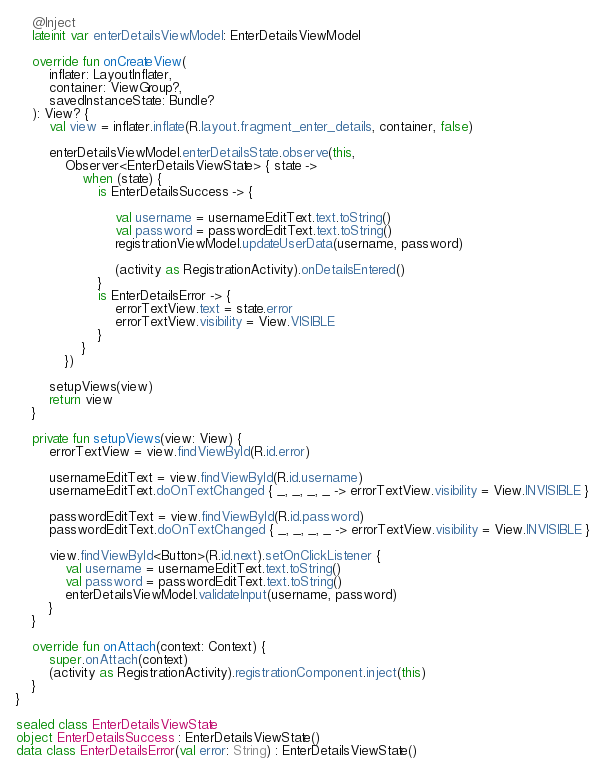<code> <loc_0><loc_0><loc_500><loc_500><_Kotlin_>    @Inject
    lateinit var enterDetailsViewModel: EnterDetailsViewModel

    override fun onCreateView(
        inflater: LayoutInflater,
        container: ViewGroup?,
        savedInstanceState: Bundle?
    ): View? {
        val view = inflater.inflate(R.layout.fragment_enter_details, container, false)

        enterDetailsViewModel.enterDetailsState.observe(this,
            Observer<EnterDetailsViewState> { state ->
                when (state) {
                    is EnterDetailsSuccess -> {

                        val username = usernameEditText.text.toString()
                        val password = passwordEditText.text.toString()
                        registrationViewModel.updateUserData(username, password)

                        (activity as RegistrationActivity).onDetailsEntered()
                    }
                    is EnterDetailsError -> {
                        errorTextView.text = state.error
                        errorTextView.visibility = View.VISIBLE
                    }
                }
            })

        setupViews(view)
        return view
    }

    private fun setupViews(view: View) {
        errorTextView = view.findViewById(R.id.error)

        usernameEditText = view.findViewById(R.id.username)
        usernameEditText.doOnTextChanged { _, _, _, _ -> errorTextView.visibility = View.INVISIBLE }

        passwordEditText = view.findViewById(R.id.password)
        passwordEditText.doOnTextChanged { _, _, _, _ -> errorTextView.visibility = View.INVISIBLE }

        view.findViewById<Button>(R.id.next).setOnClickListener {
            val username = usernameEditText.text.toString()
            val password = passwordEditText.text.toString()
            enterDetailsViewModel.validateInput(username, password)
        }
    }

    override fun onAttach(context: Context) {
        super.onAttach(context)
        (activity as RegistrationActivity).registrationComponent.inject(this)
    }
}

sealed class EnterDetailsViewState
object EnterDetailsSuccess : EnterDetailsViewState()
data class EnterDetailsError(val error: String) : EnterDetailsViewState()
</code> 